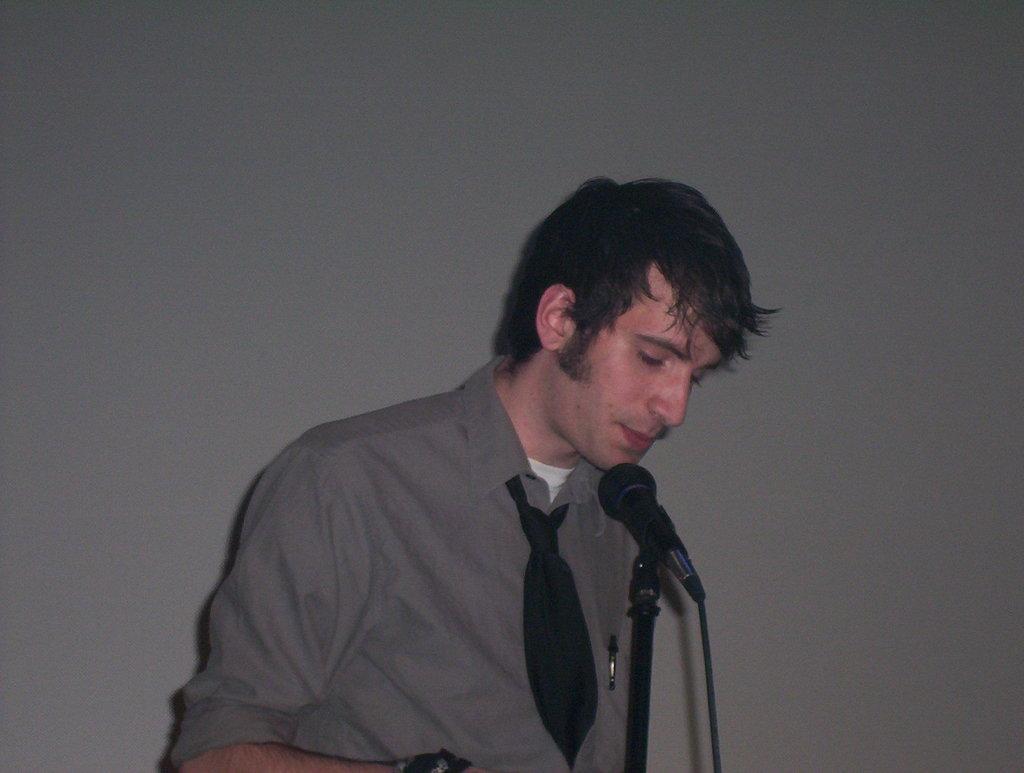Describe this image in one or two sentences. In this image I can see a man and I can see he is wearing shirt and a black tie. I can also see a mic in the front of him. 